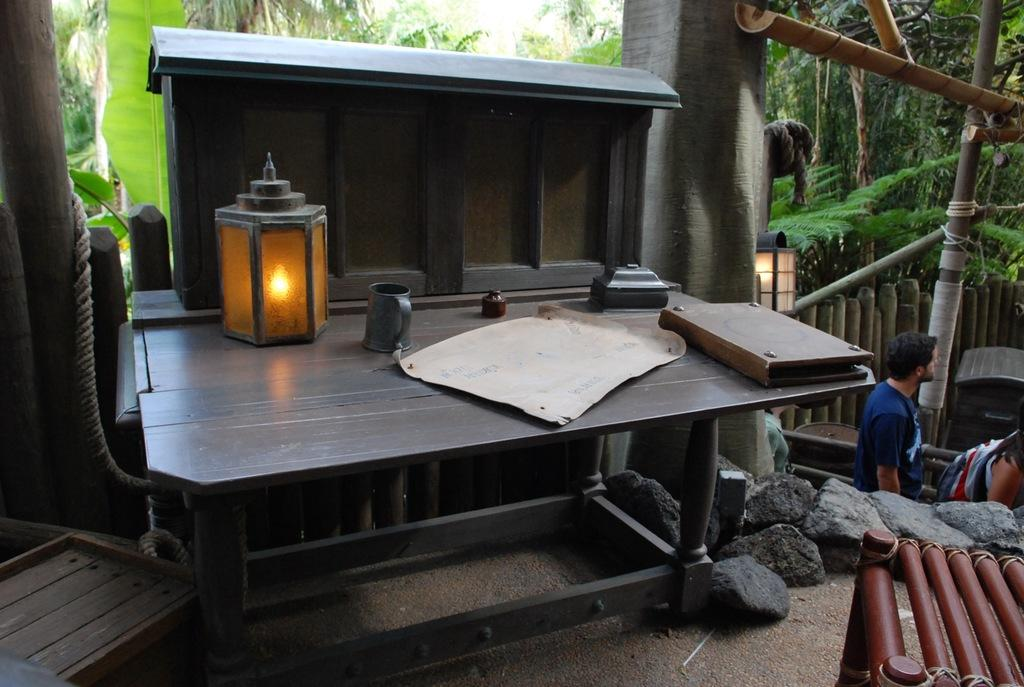Who or what is present in the image? There is a person in the image. What can be seen illuminating the scene? There is a light in the image. What objects related to reading or writing are visible? There is a paper and a book in the image. What type of natural scenery is visible in the background? There are trees in the background of the image. How many clocks are visible in the image? There are no clocks present in the image. What type of minute is depicted in the image? There is no depiction of a minute in the image. 